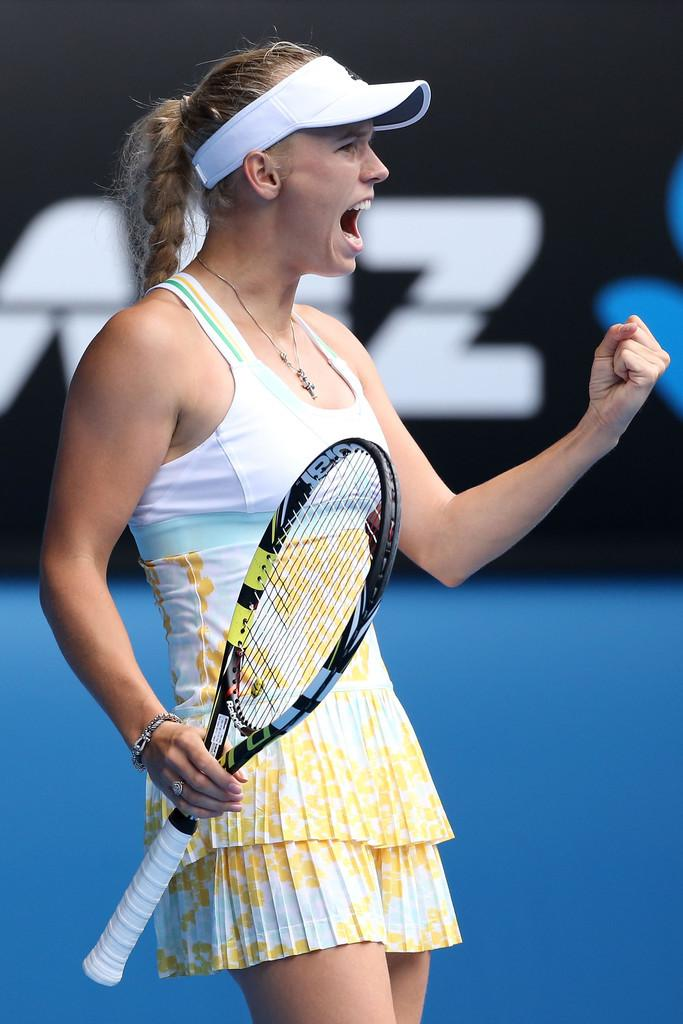Who is the main subject in the image? There is a woman in the image. What is the woman doing in the image? The woman is standing and screaming loudly. What object is the woman holding in her hands? The woman is holding a racket in her hands. What songs can be heard playing in the background of the image? There is no information about songs or background music in the image, so it cannot be determined from the image. 